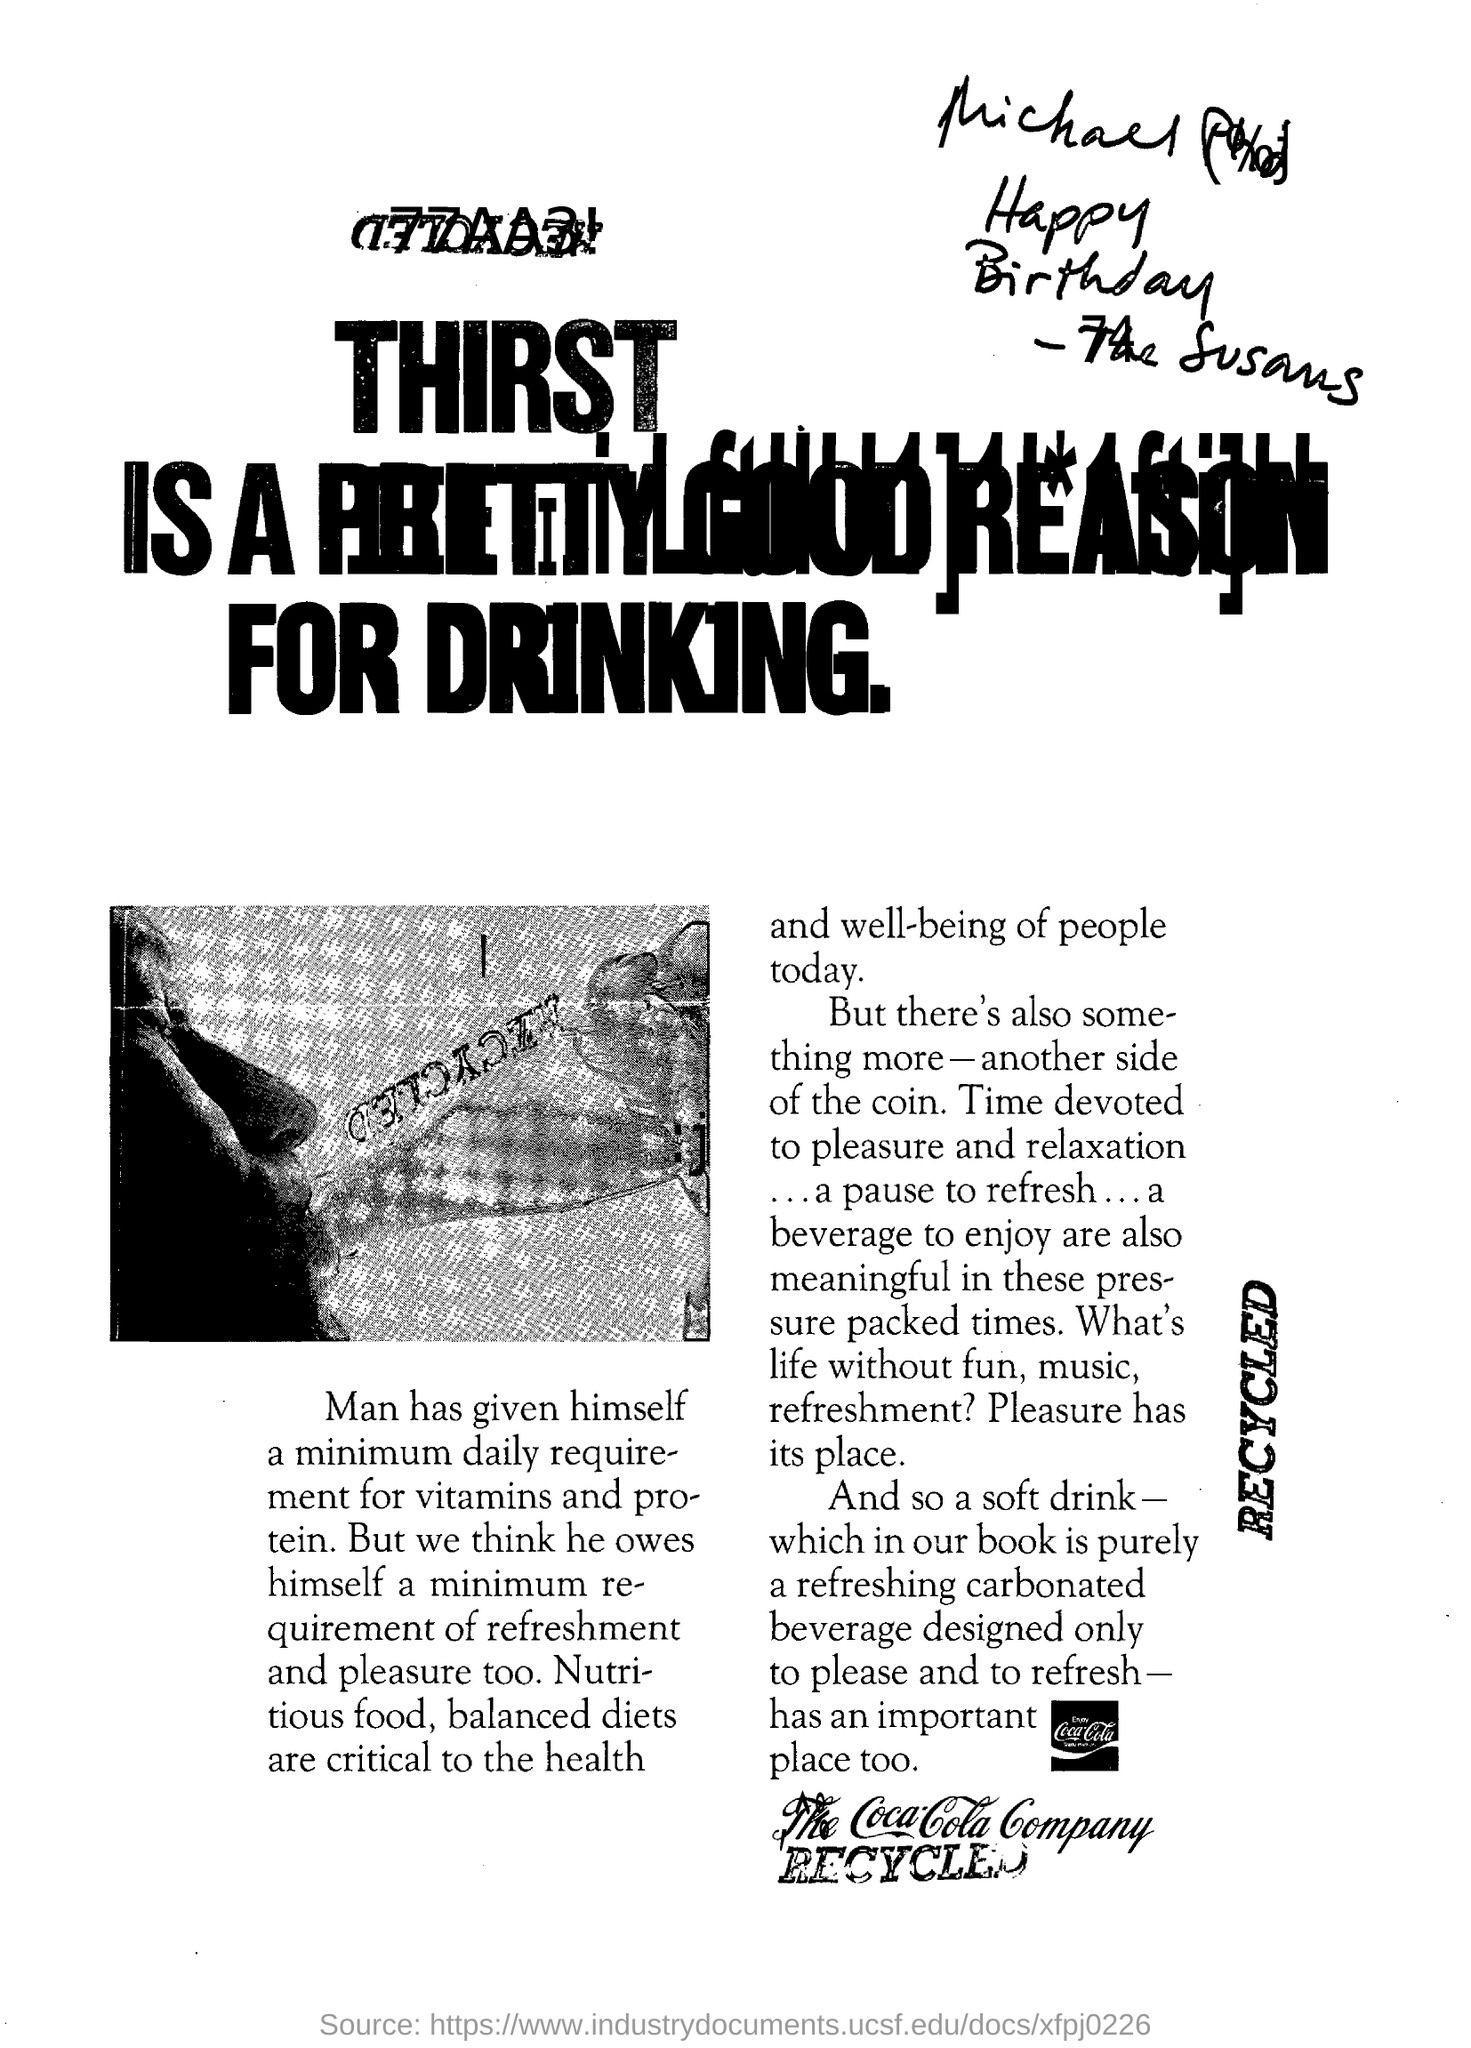Point out several critical features in this image. The Coca-Cola company is the name of a company. Access to nutritious food and balanced diets is essential for the well-being of individuals in today's society. It is clear that thirst is a valid reason for drinking, as stated in the heading of this document. 